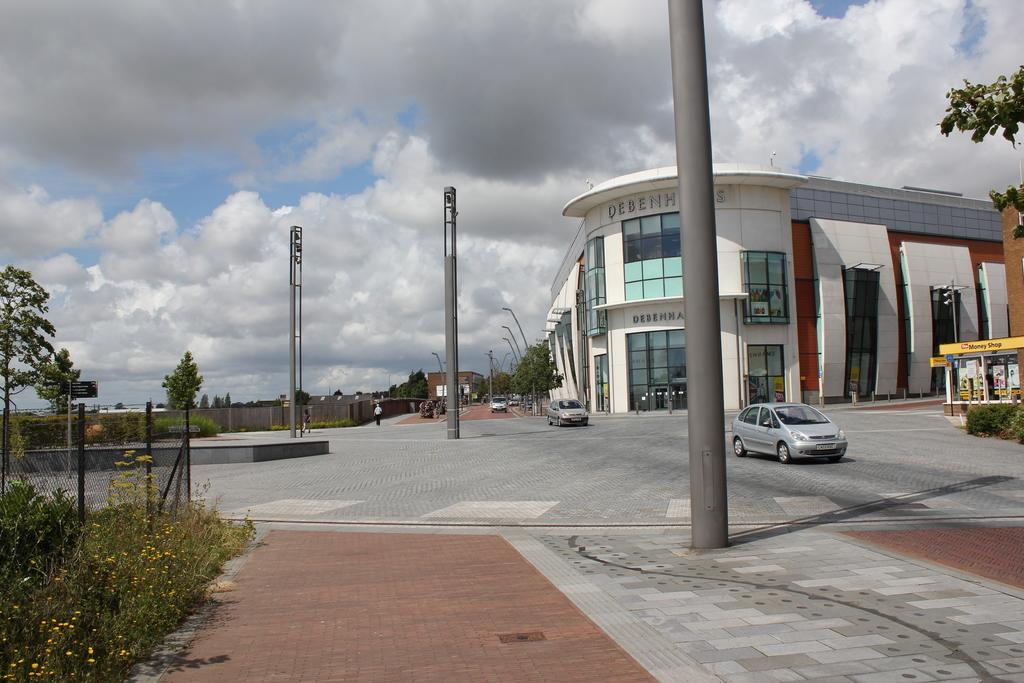What can be seen on the road in the image? There are vehicles on the road in the image. Are there any people visible on the road? Yes, there is a person on the road in the image. What type of structures can be seen in the image? There are buildings in the image. What other objects can be seen in the image? There are poles, plants with flowers, and a fence in the image. What is visible in the background of the image? There are trees and the sky visible in the background of the image. How many worms can be seen crawling on the wheel in the image? There are no worms or wheels present in the image. What type of twist can be seen in the image? There is no twist visible in the image. 